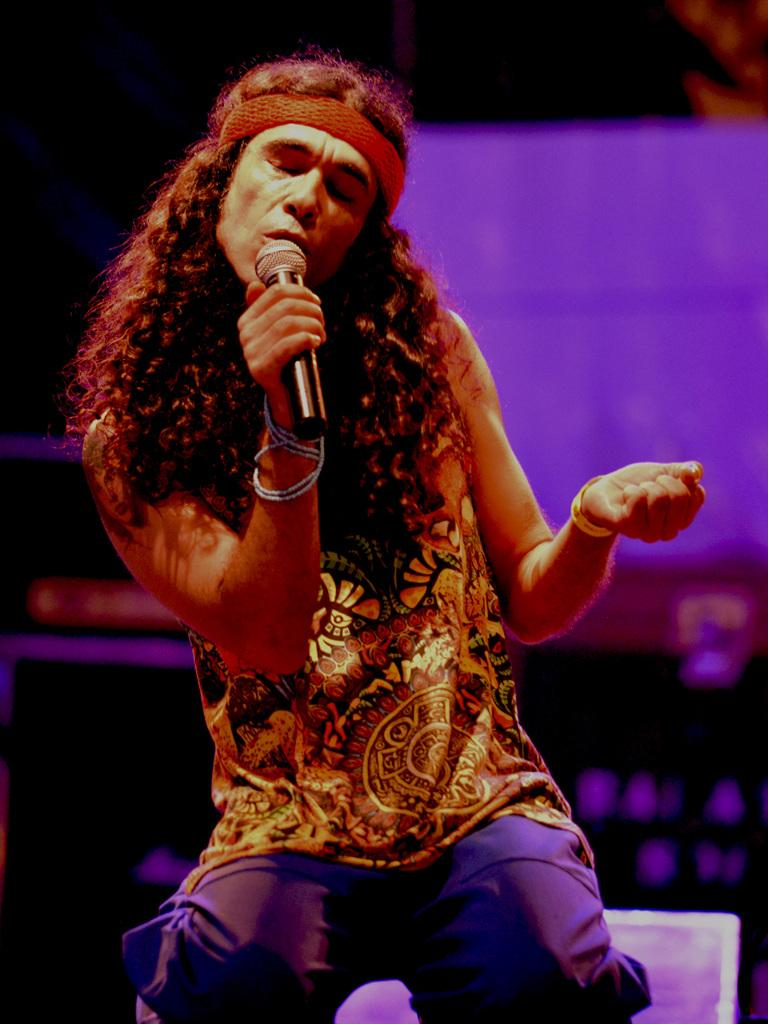Who is the main subject in the image? There is a person in the image. What is the person holding in the image? The person is holding a microphone. What is the person doing in the image? The person is singing. Can you describe the background of the image? The background of the image is blurred. What type of dirt can be seen on the table during the feast in the image? There is no feast or dirt present in the image; it features a person singing while holding a microphone. 